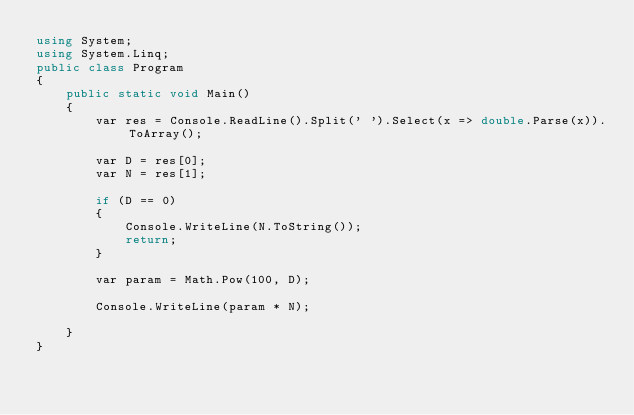<code> <loc_0><loc_0><loc_500><loc_500><_C#_>using System;
using System.Linq;
public class Program
{
    public static void Main()
    {
        var res = Console.ReadLine().Split(' ').Select(x => double.Parse(x)).ToArray();

        var D = res[0];
        var N = res[1];

        if (D == 0)
        {
            Console.WriteLine(N.ToString());
            return;
        }

        var param = Math.Pow(100, D);

        Console.WriteLine(param * N);

    }
}</code> 